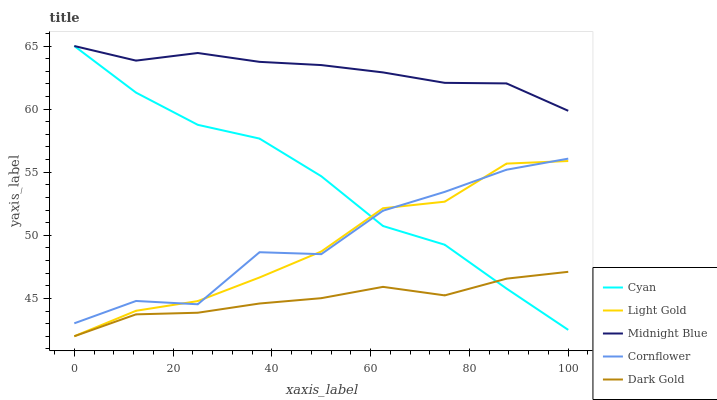Does Dark Gold have the minimum area under the curve?
Answer yes or no. Yes. Does Midnight Blue have the maximum area under the curve?
Answer yes or no. Yes. Does Light Gold have the minimum area under the curve?
Answer yes or no. No. Does Light Gold have the maximum area under the curve?
Answer yes or no. No. Is Midnight Blue the smoothest?
Answer yes or no. Yes. Is Cornflower the roughest?
Answer yes or no. Yes. Is Dark Gold the smoothest?
Answer yes or no. No. Is Dark Gold the roughest?
Answer yes or no. No. Does Midnight Blue have the lowest value?
Answer yes or no. No. Does Midnight Blue have the highest value?
Answer yes or no. Yes. Does Light Gold have the highest value?
Answer yes or no. No. Is Dark Gold less than Cornflower?
Answer yes or no. Yes. Is Cornflower greater than Dark Gold?
Answer yes or no. Yes. Does Light Gold intersect Cyan?
Answer yes or no. Yes. Is Light Gold less than Cyan?
Answer yes or no. No. Is Light Gold greater than Cyan?
Answer yes or no. No. Does Dark Gold intersect Cornflower?
Answer yes or no. No. 